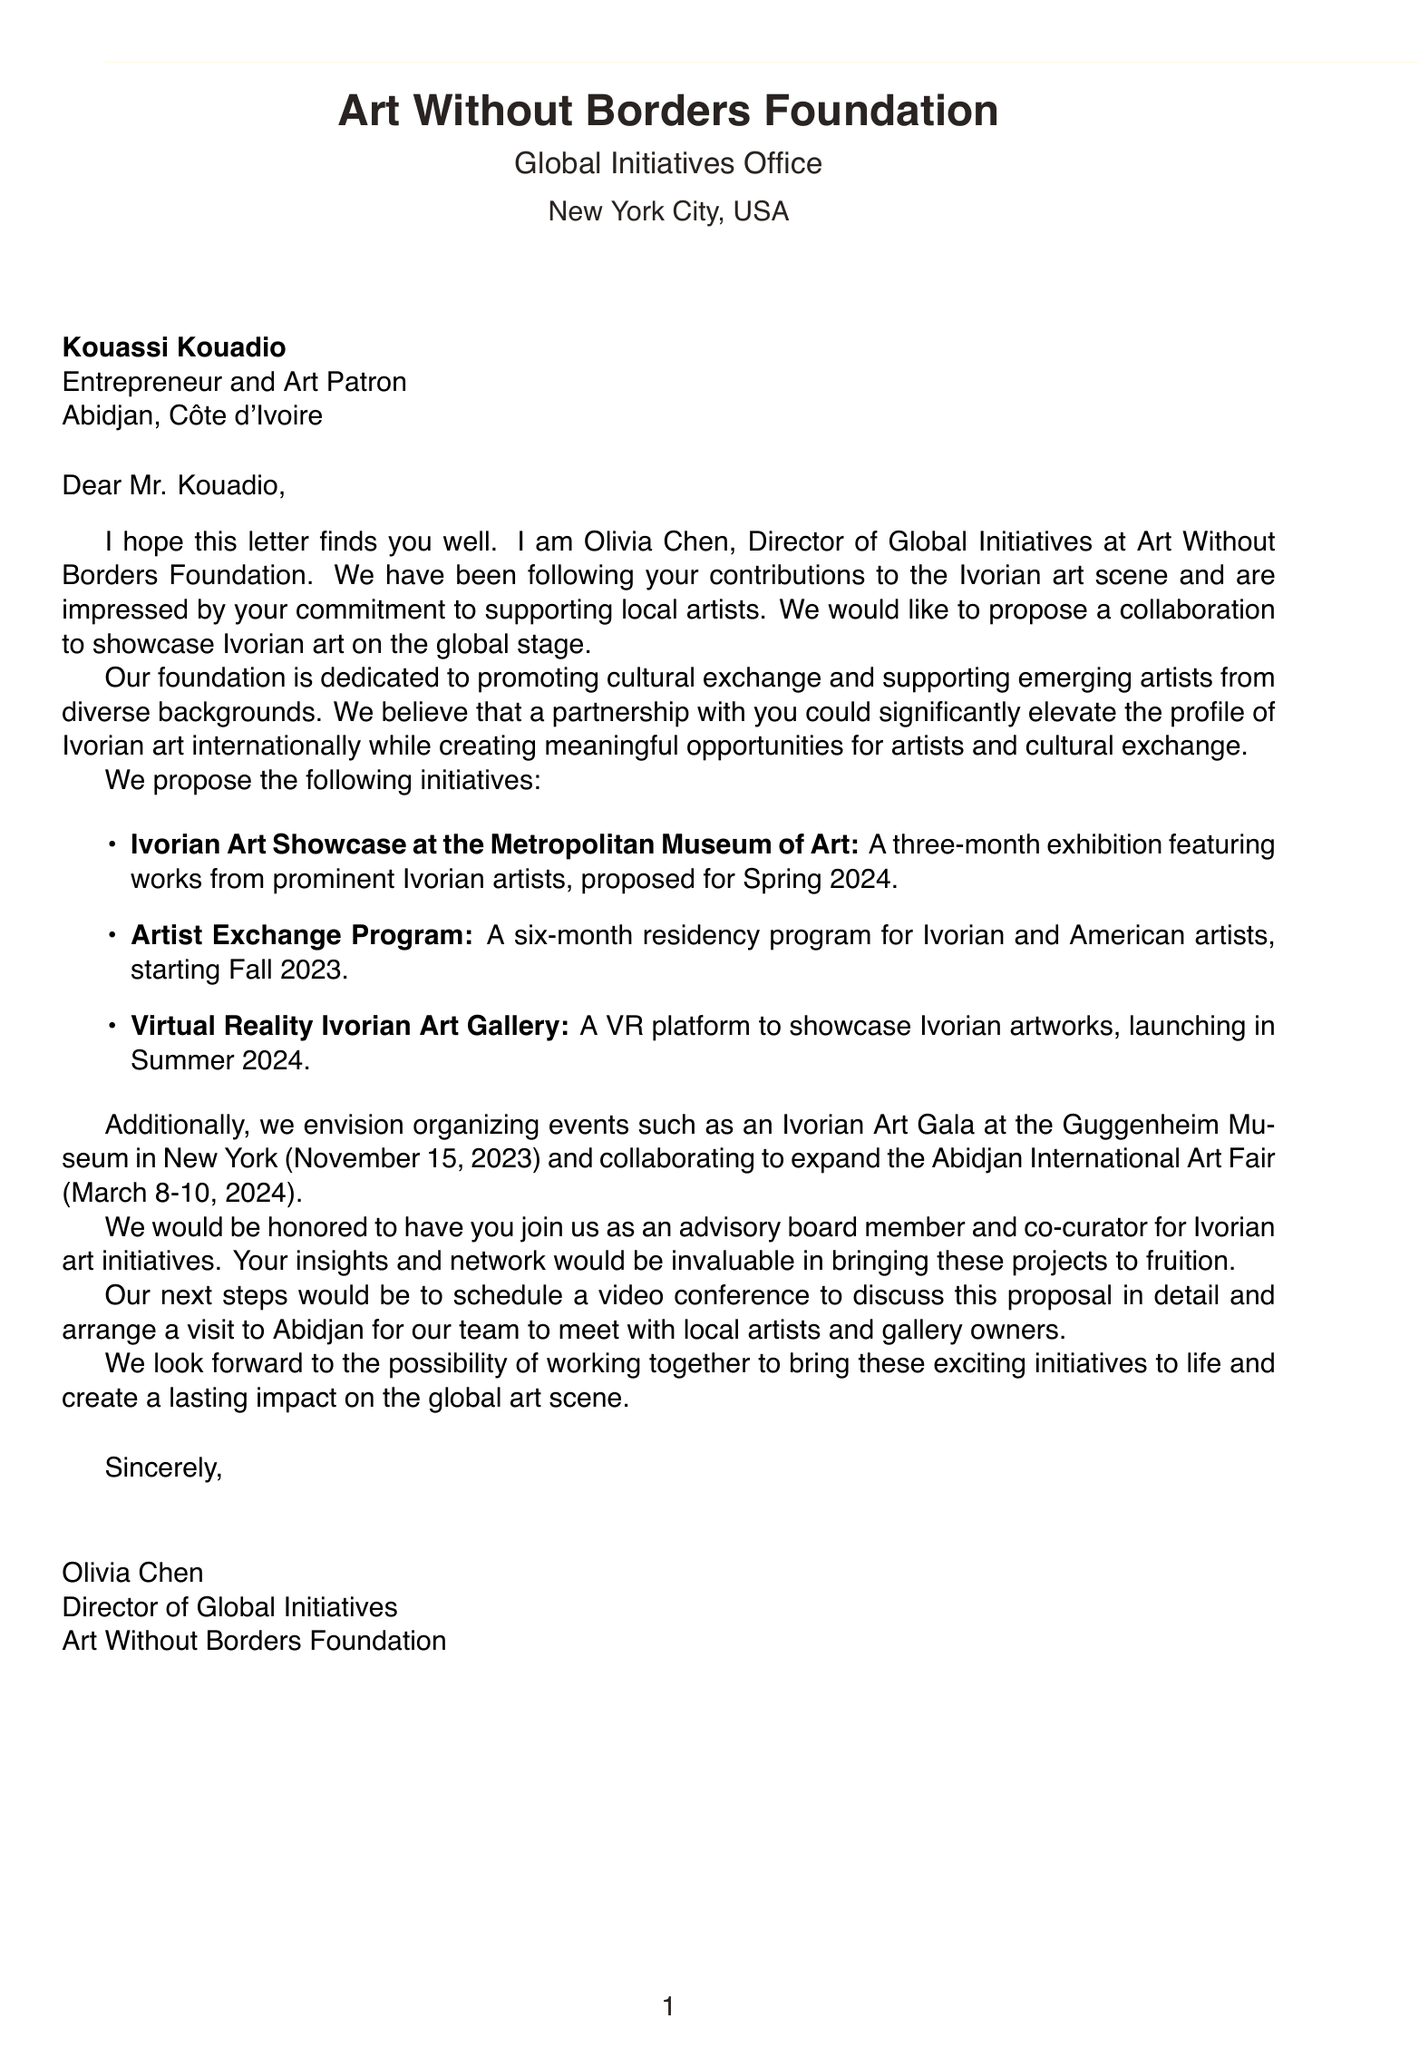What is the name of the sender? The sender's name is mentioned in the introduction section of the document.
Answer: Olivia Chen What is the primary aim of the Art Without Borders Foundation? The background information clearly states the foundation's purpose.
Answer: Promoting cultural exchange What event is scheduled for November 15, 2023? The proposed events section details specific dates for events.
Answer: Ivorian Art Gala What is the proposed timeline for the Ivorian Art Showcase? The document explicitly states the timeline for the proposed showcase.
Answer: Spring 2024 How many Ivorian artists are planned to participate in the Artist Exchange Program? The description provides specific details regarding the residency program's participants.
Answer: Two What location will host the Abidjan International Art Fair? The proposed events section includes locations for the listed events.
Answer: Sofitel Abidjan Hotel Ivoire What role is being requested from Kouassi Kouadio? The request for involvement section specifies the role intended for the recipient.
Answer: Advisory board member What are the expected visitors for the Metropolitan Museum of Art exhibition? The expected impact section mentions the number of visitors anticipated for the exhibition.
Answer: Over 1 million visitors What is the main benefit of the partnership for Ivorian artists? The partnership benefits section highlights key advantages for artists from the collaboration.
Answer: Increased global visibility 